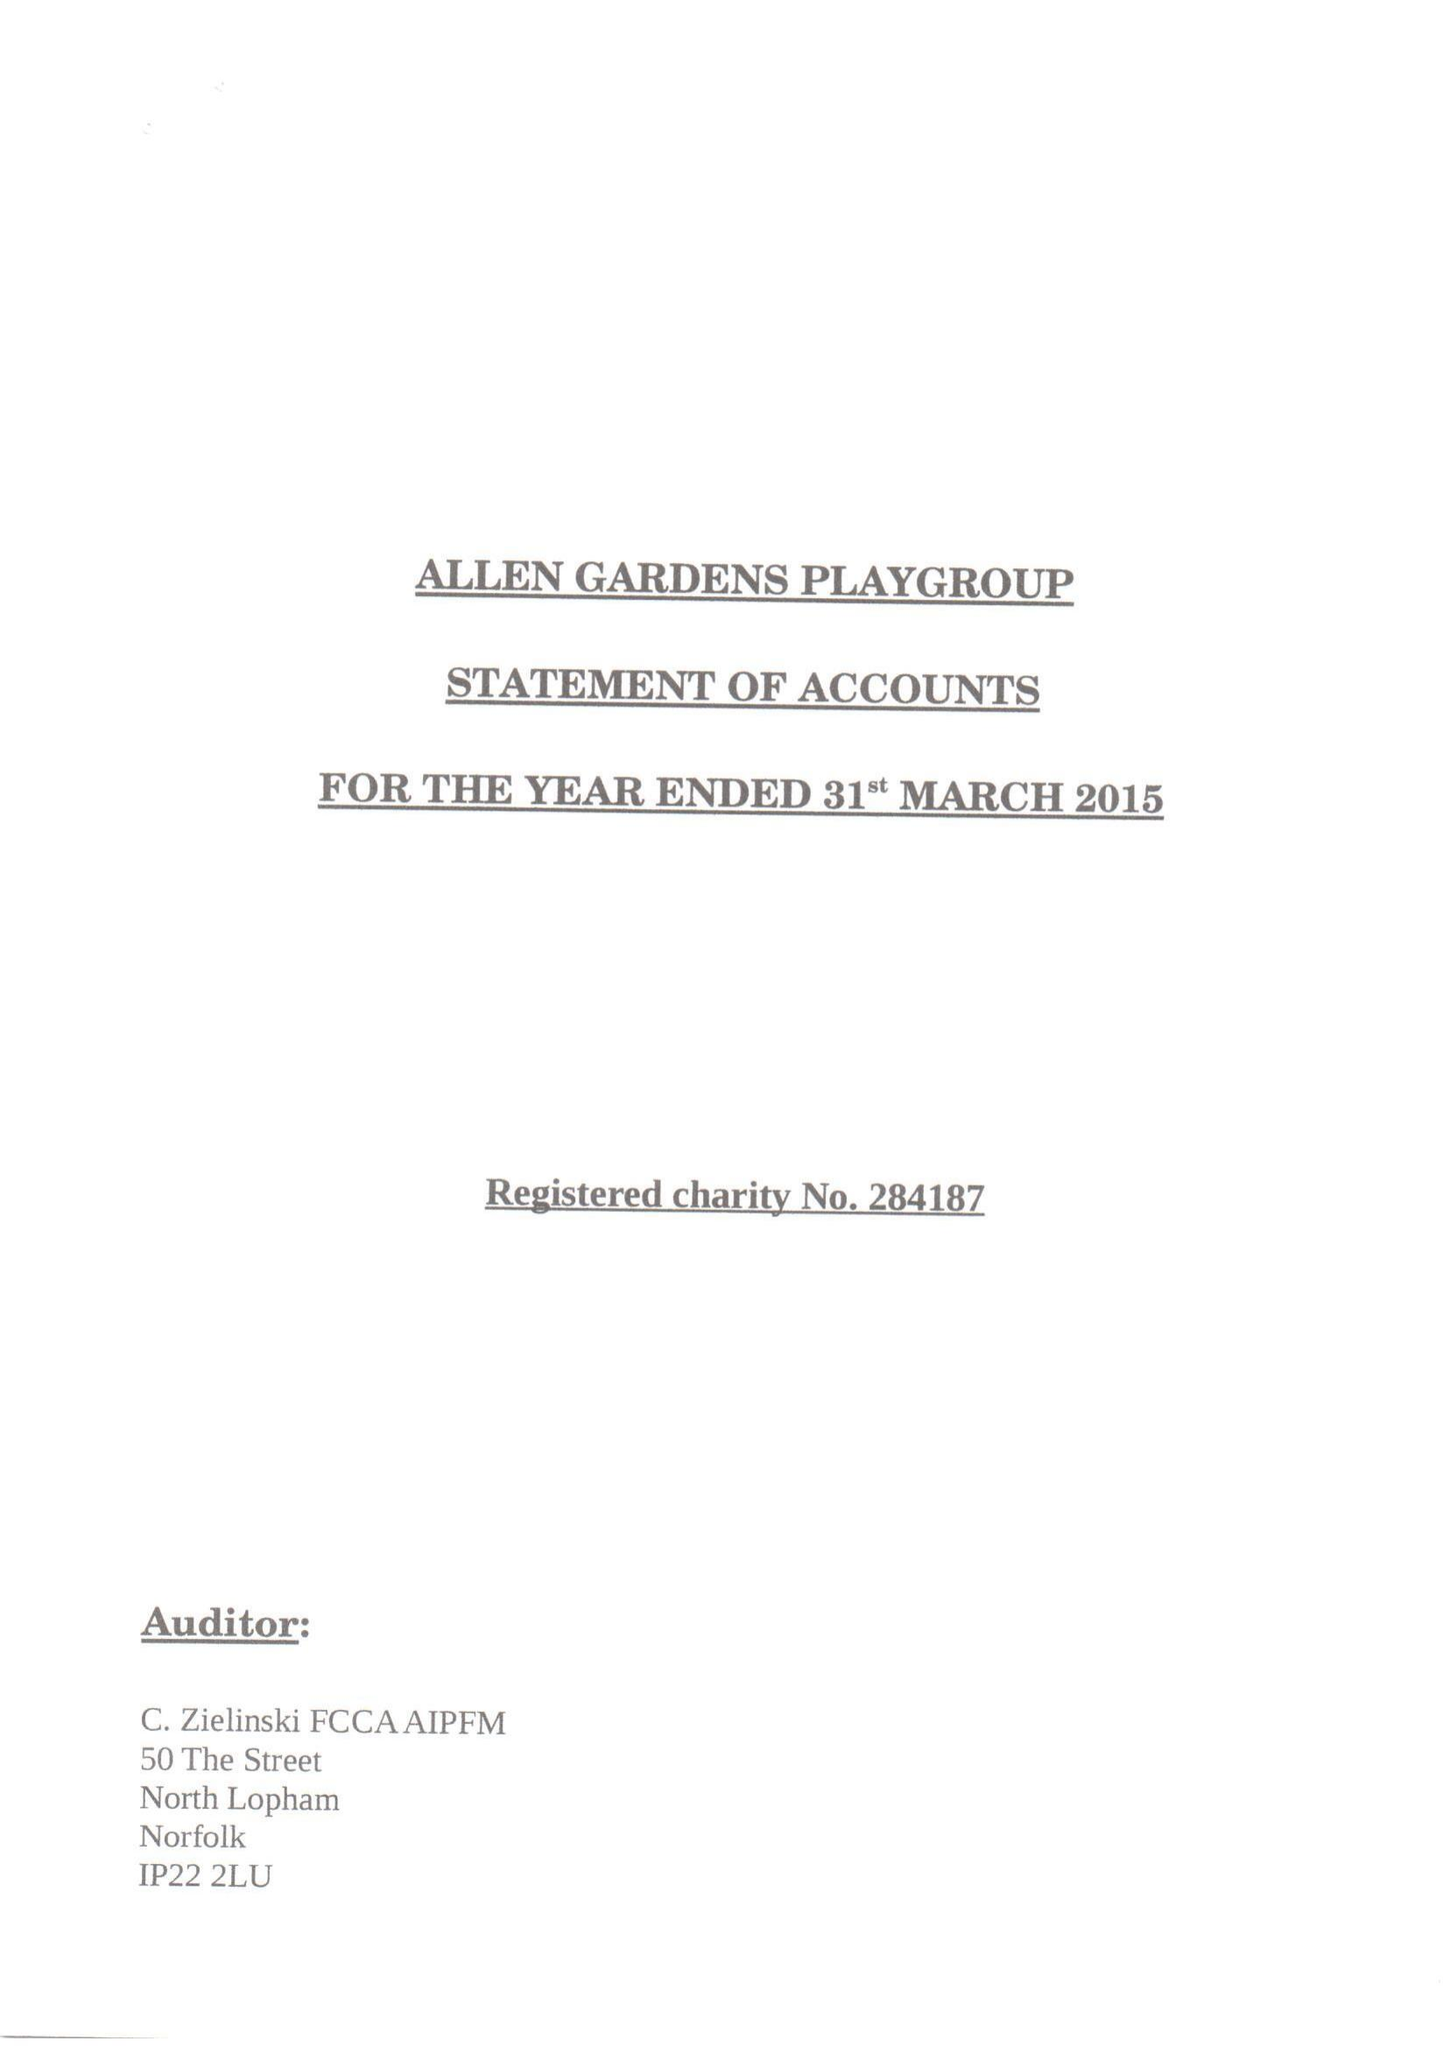What is the value for the charity_name?
Answer the question using a single word or phrase. Allen Gardens Playgroup 